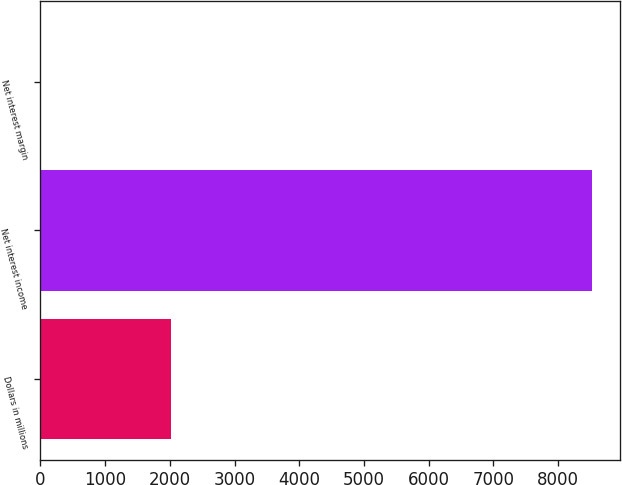<chart> <loc_0><loc_0><loc_500><loc_500><bar_chart><fcel>Dollars in millions<fcel>Net interest income<fcel>Net interest margin<nl><fcel>2014<fcel>8525<fcel>3.08<nl></chart> 